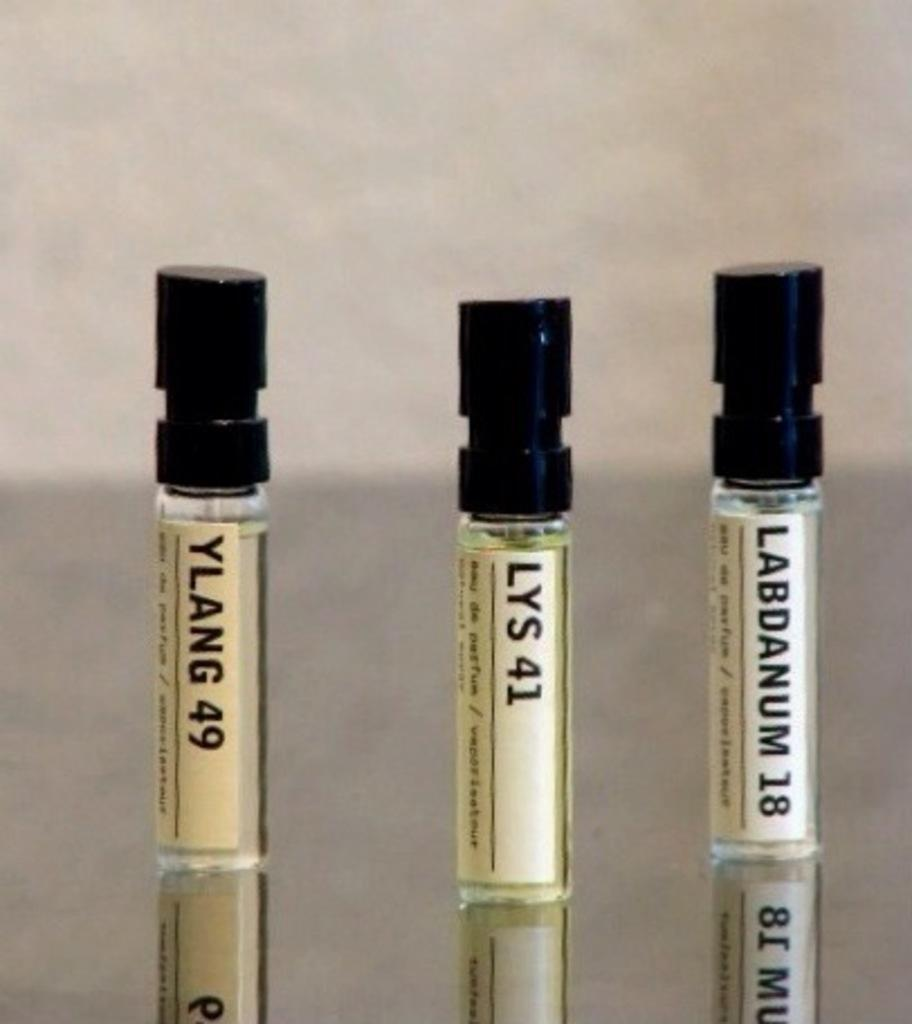<image>
Provide a brief description of the given image. A vial of YLANG 49 sits next to a vial of LYS 41. 